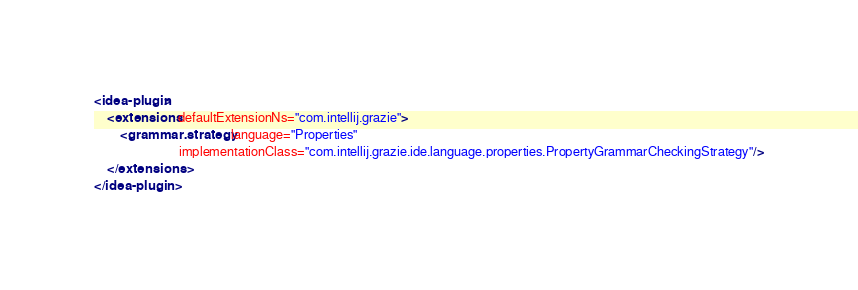<code> <loc_0><loc_0><loc_500><loc_500><_XML_><idea-plugin>
    <extensions defaultExtensionNs="com.intellij.grazie">
        <grammar.strategy language="Properties"
                          implementationClass="com.intellij.grazie.ide.language.properties.PropertyGrammarCheckingStrategy"/>
    </extensions>
</idea-plugin>
</code> 